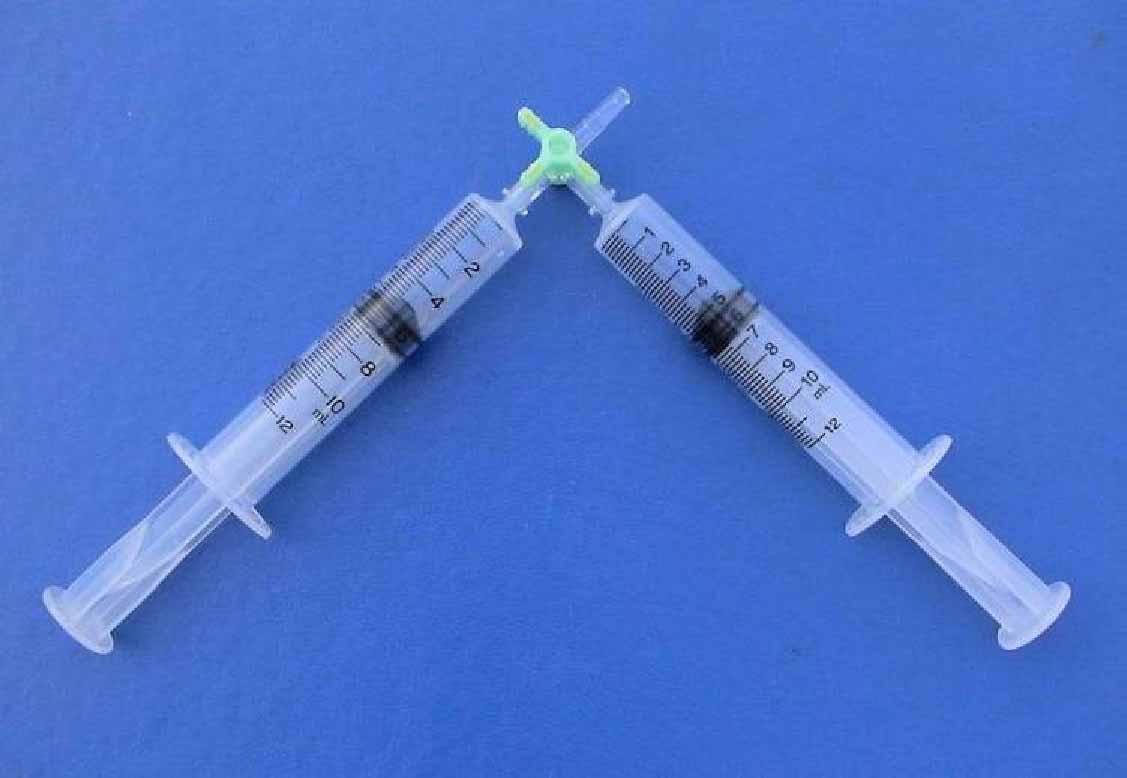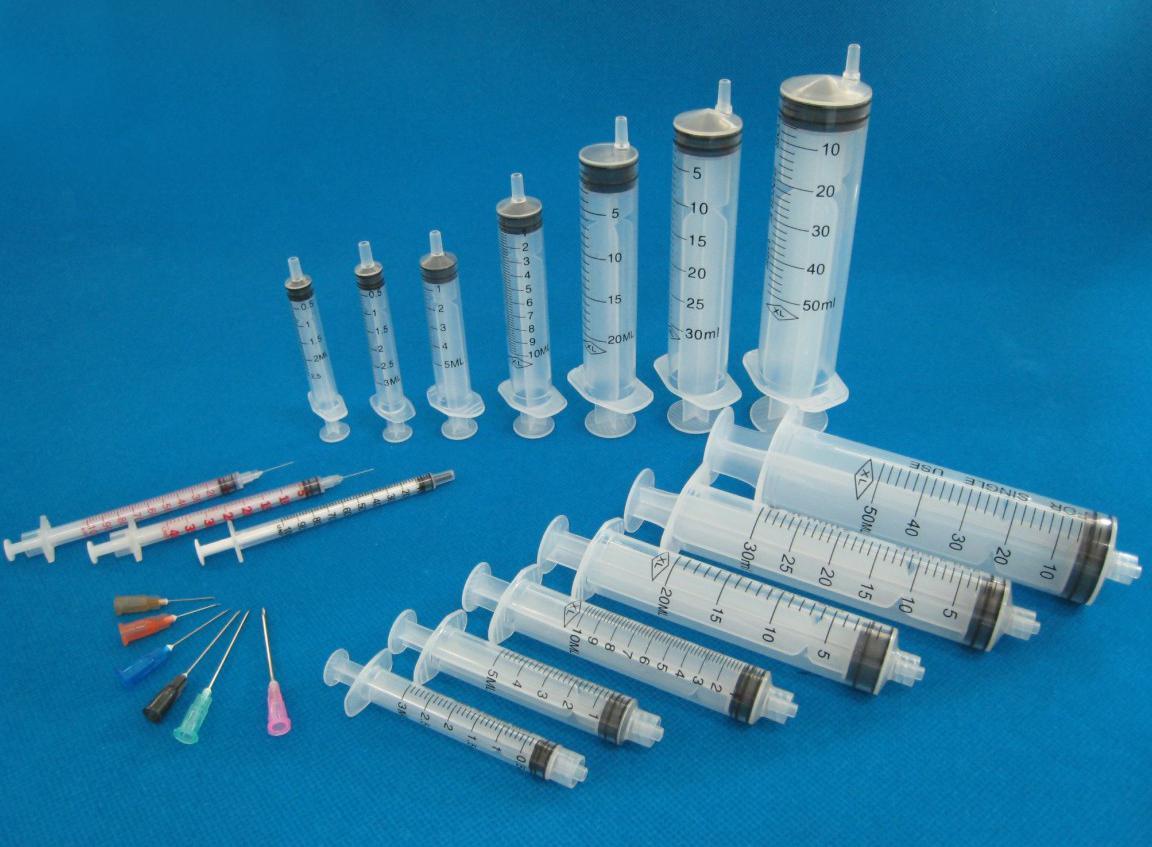The first image is the image on the left, the second image is the image on the right. Considering the images on both sides, is "One of the images contains more than five syringes." valid? Answer yes or no. Yes. 